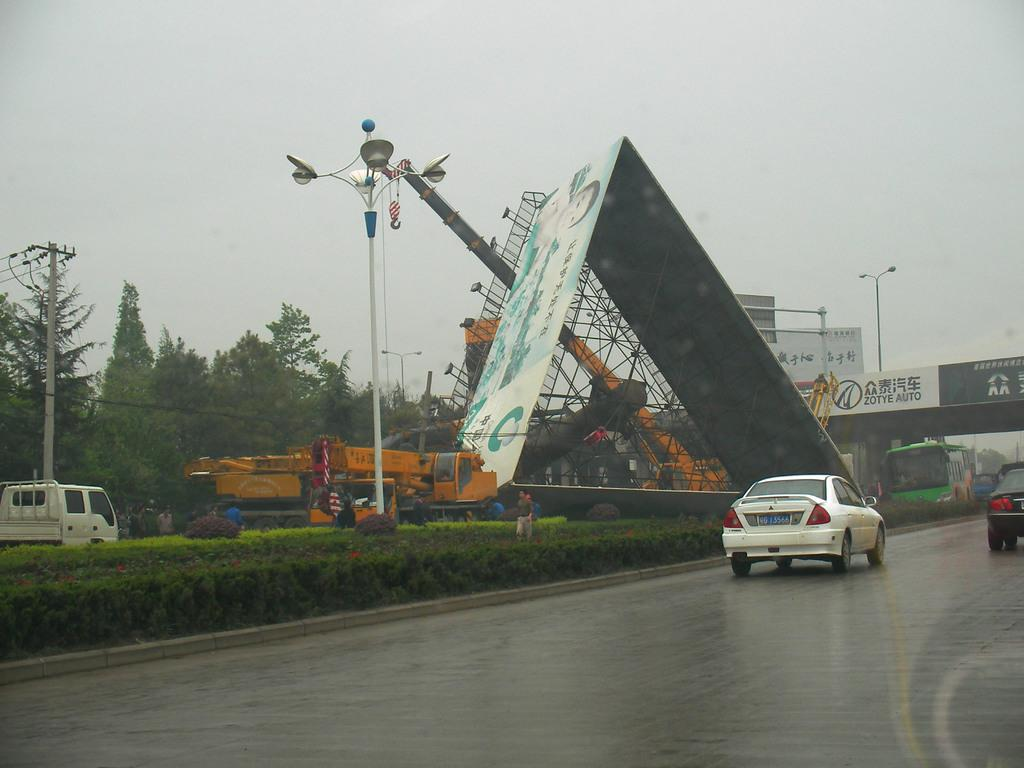What is happening in the main part of the image? There are vehicles moving on a road in the image. What can be seen in the middle of the image? There are plants and poles in the middle of the image. What is visible in the background of the image? There are trees, hoardings, and the sky visible in the background of the image. Where is the throne located in the image? There is no throne present in the image. How many brothers are visible in the image? There are no people, let alone brothers, visible in the image. 